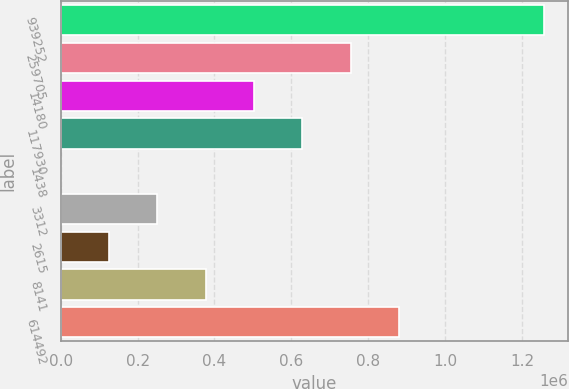Convert chart to OTSL. <chart><loc_0><loc_0><loc_500><loc_500><bar_chart><fcel>939252<fcel>259705<fcel>14180<fcel>117930<fcel>1438<fcel>3312<fcel>2615<fcel>8141<fcel>614492<nl><fcel>1.25725e+06<fcel>754357<fcel>502912<fcel>628635<fcel>21.42<fcel>251467<fcel>125744<fcel>377189<fcel>880080<nl></chart> 